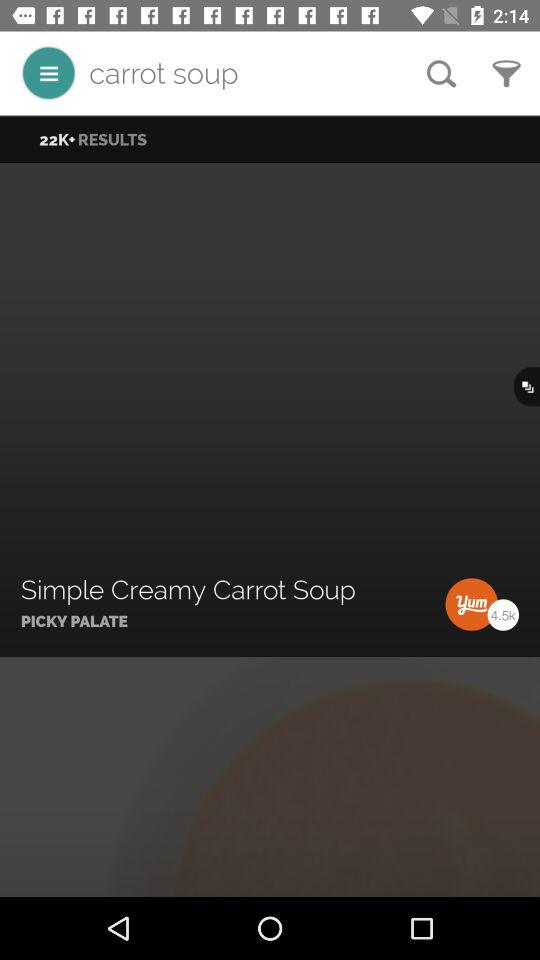How many results in total are there? There are a total of 22,000 results. 